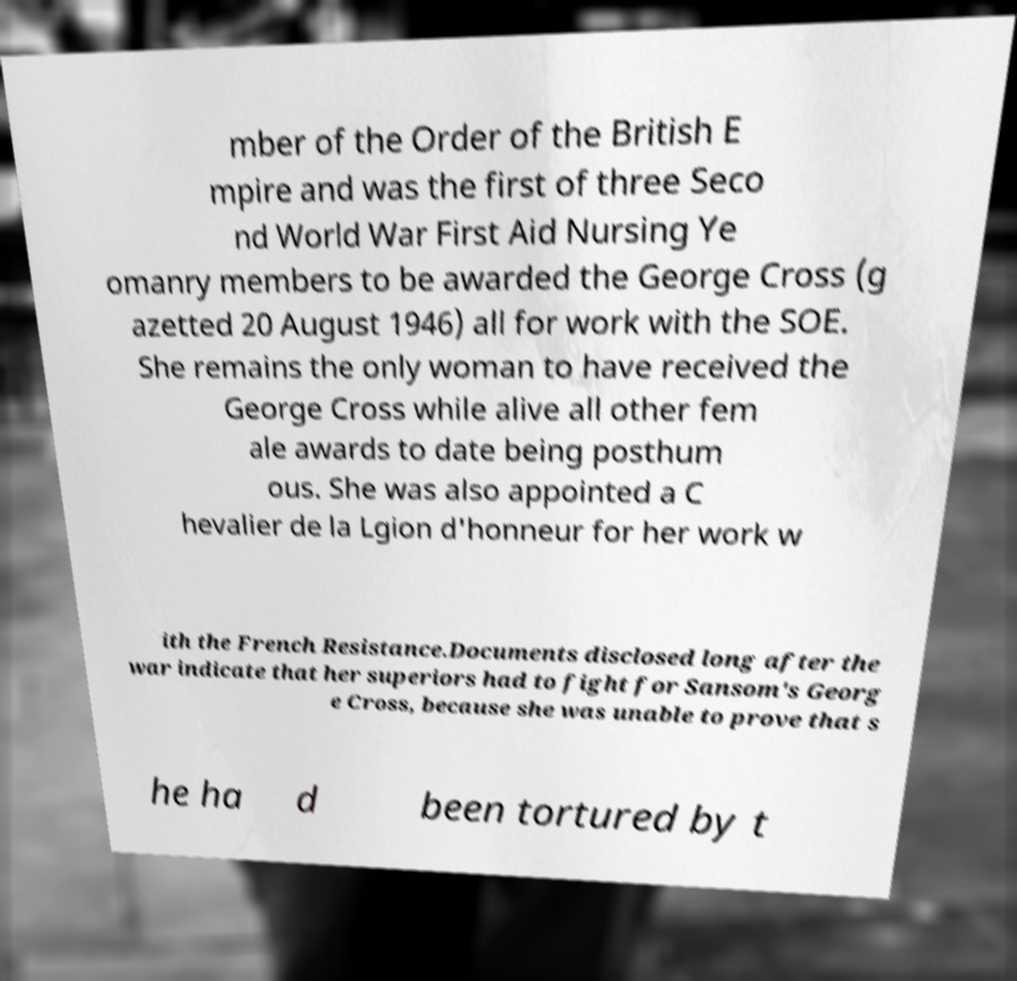There's text embedded in this image that I need extracted. Can you transcribe it verbatim? mber of the Order of the British E mpire and was the first of three Seco nd World War First Aid Nursing Ye omanry members to be awarded the George Cross (g azetted 20 August 1946) all for work with the SOE. She remains the only woman to have received the George Cross while alive all other fem ale awards to date being posthum ous. She was also appointed a C hevalier de la Lgion d'honneur for her work w ith the French Resistance.Documents disclosed long after the war indicate that her superiors had to fight for Sansom's Georg e Cross, because she was unable to prove that s he ha d been tortured by t 